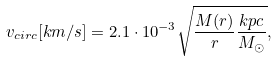<formula> <loc_0><loc_0><loc_500><loc_500>v _ { c i r c } [ k m / s ] = 2 . 1 \cdot 1 0 ^ { - 3 } \sqrt { \frac { M ( r ) } { r } \frac { k p c } { M _ { \odot } } } ,</formula> 